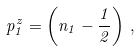<formula> <loc_0><loc_0><loc_500><loc_500>p _ { 1 } ^ { z } = \left ( n _ { 1 } - \frac { 1 } { 2 } \right ) \, ,</formula> 